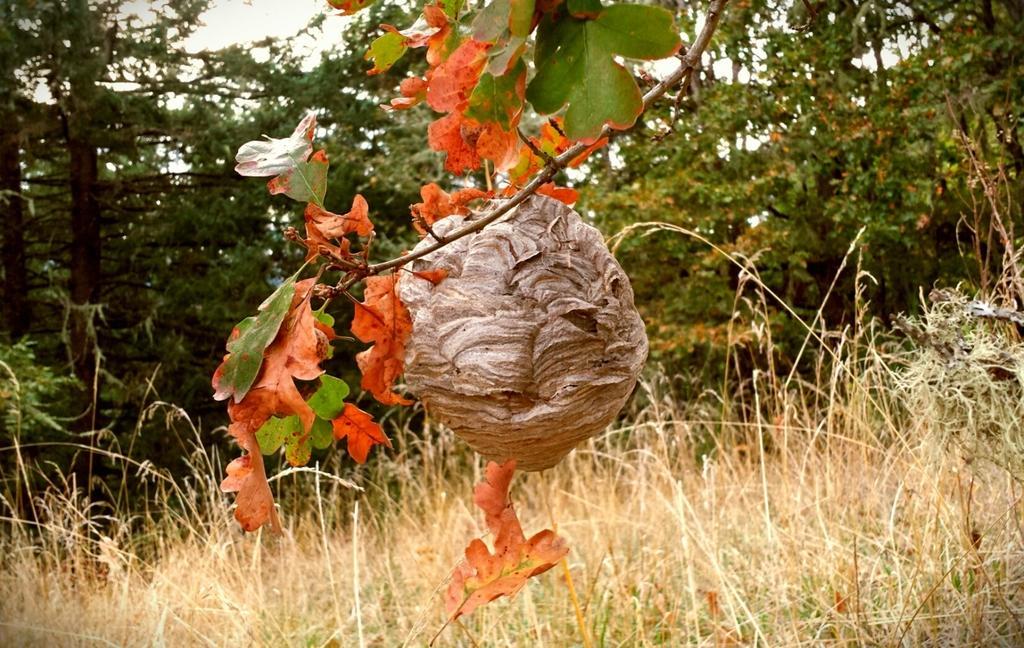How would you summarize this image in a sentence or two? In this picture there are trees and there is a nest in the foreground. At the top there is sky. At the bottom there is grass. 